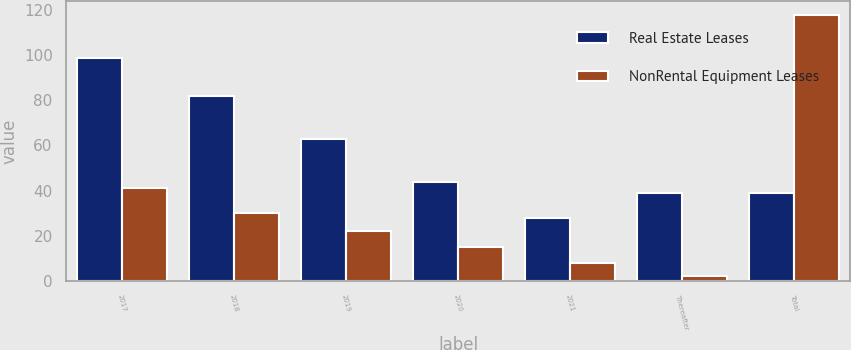<chart> <loc_0><loc_0><loc_500><loc_500><stacked_bar_chart><ecel><fcel>2017<fcel>2018<fcel>2019<fcel>2020<fcel>2021<fcel>Thereafter<fcel>Total<nl><fcel>Real Estate Leases<fcel>99<fcel>82<fcel>63<fcel>44<fcel>28<fcel>39<fcel>39<nl><fcel>NonRental Equipment Leases<fcel>41<fcel>30<fcel>22<fcel>15<fcel>8<fcel>2<fcel>118<nl></chart> 